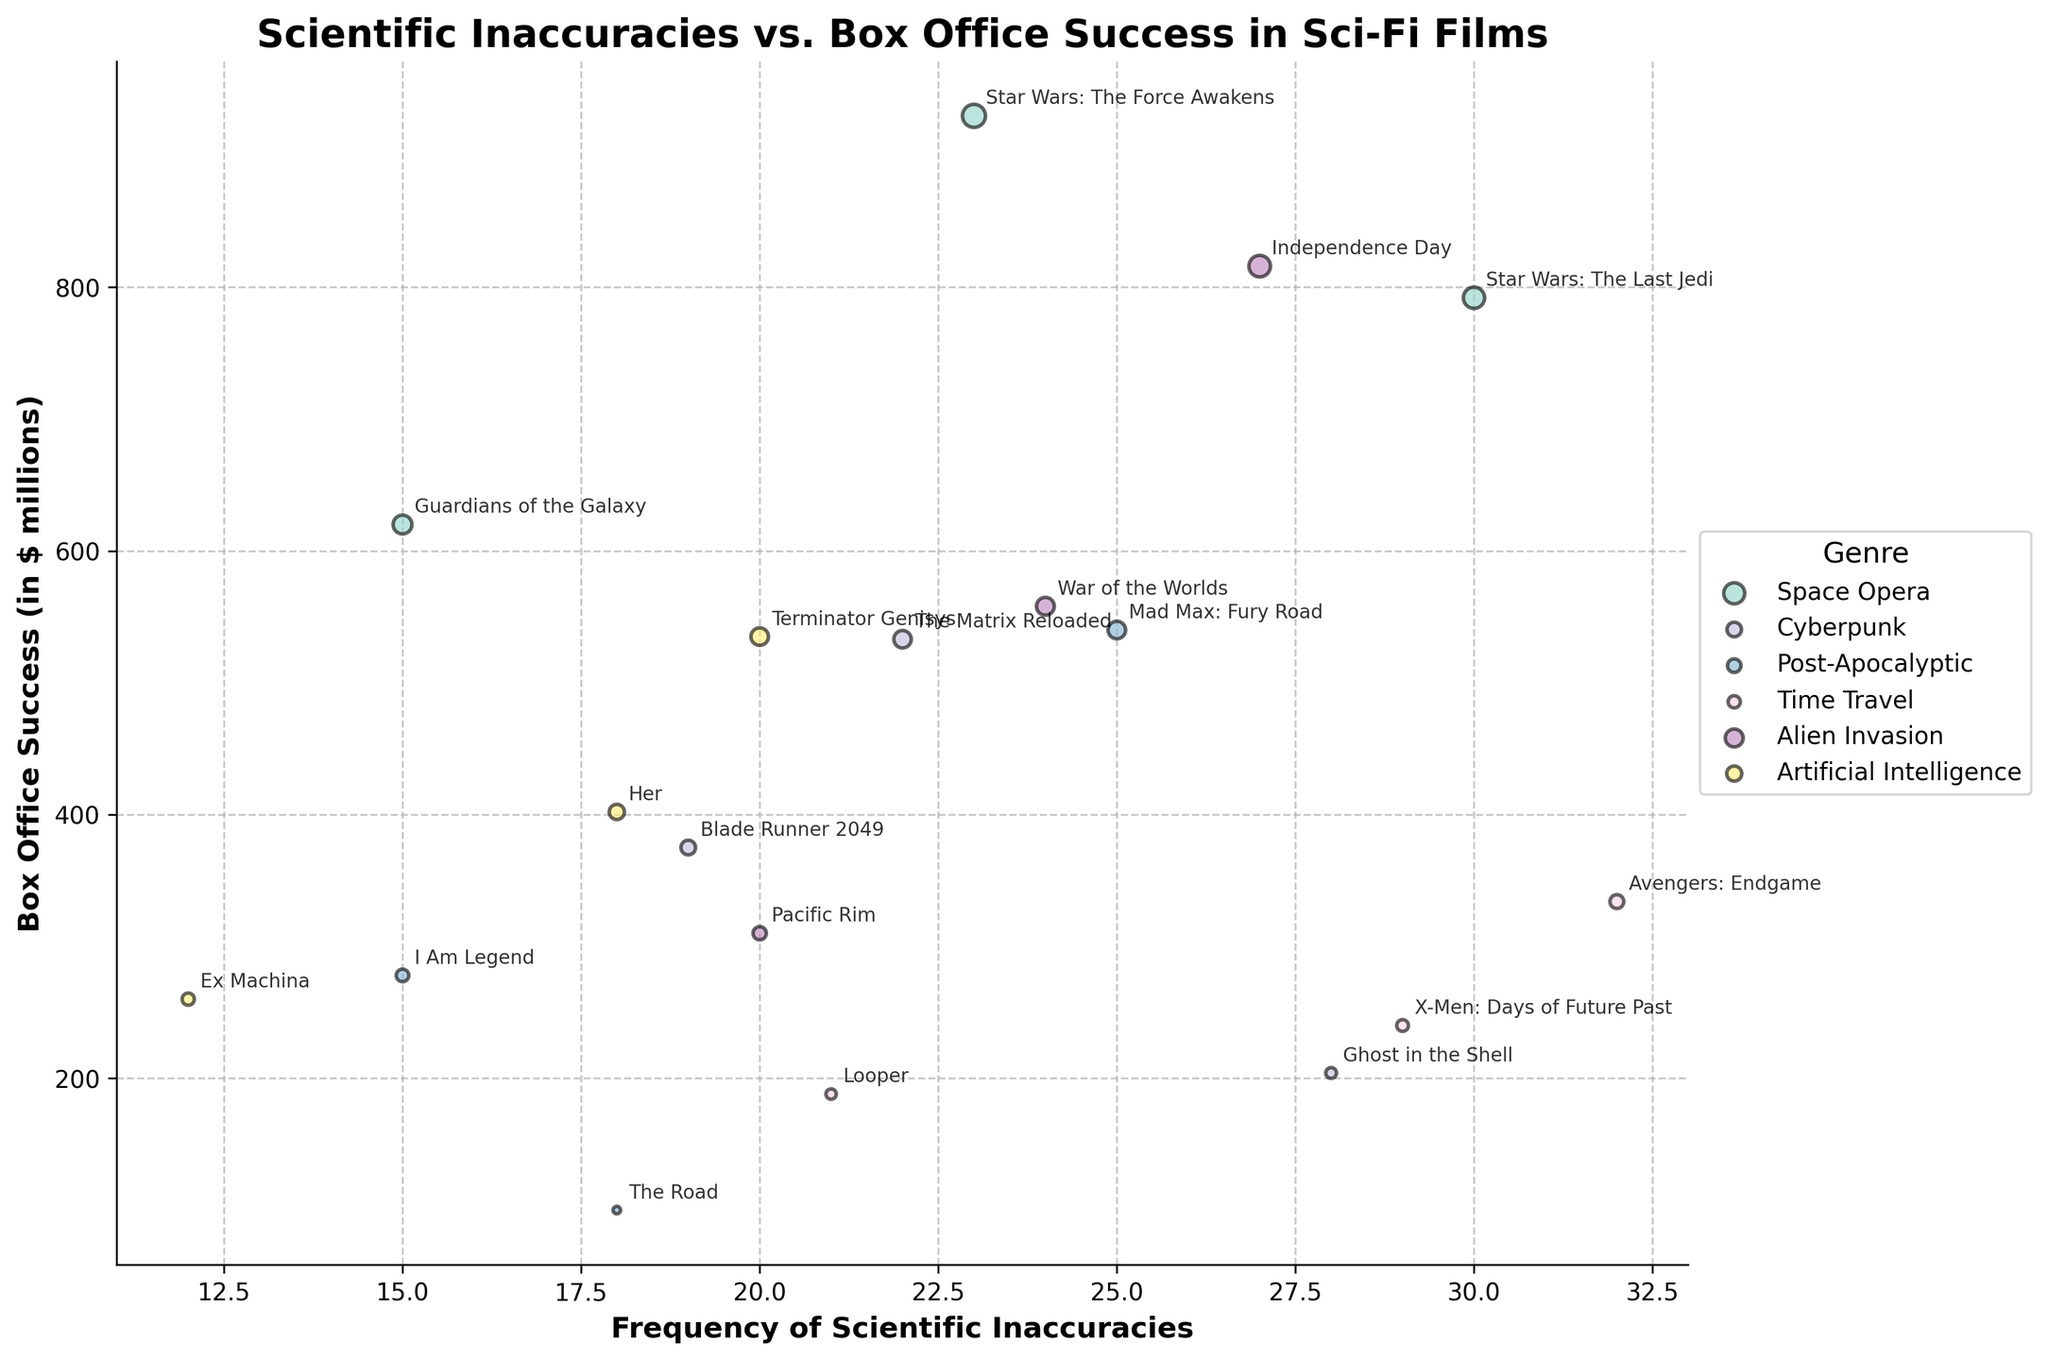How many genres are represented in the figure? The figure uses different colors to represent various genres. Based on the color legend, we can count the number of distinct genres.
Answer: 5 Which film has the highest frequency of scientific inaccuracies, and what genre does it belong to? The film with the highest frequency of scientific inaccuracies has the furthest right bubble. This film is "Avengers: Endgame," and belongs to the "Time Travel" genre.
Answer: Avengers: Endgame, Time Travel What is the average box office success of the "Cyberpunk" genre films? Sum the box office success of all "Cyberpunk" films and divide by the number of films in this genre. The films are "Blade Runner 2049" ($375M), "Ghost in the Shell" ($204M), and "The Matrix Reloaded" ($533M). The total is $375 + $204 + $533 = $1112M, divided by 3 films, so the average is $1112/3 ≈ $370.67M.
Answer: $370.67M Which genre has the most consistent frequency of scientific inaccuracies? Consistency can be inferred from how close the bubbles are horizontally (same frequency). Observing the genres, "Artificial Intelligence" exhibits clusters of bubbles close in frequency (12, 18, 20), indicating consistency.
Answer: Artificial Intelligence What is the overall range of box office success observed in the figure? The range is determined by the difference between the highest and lowest box office success values. The highest is "Star Wars: The Force Awakens" with $930M and the lowest is "The Road" with $100M. The range is $930M - $100M = $830M.
Answer: $830M Are there any outliers in the frequency of scientific inaccuracies? If so, which film(s) are they? Outliers can be identified as bubbles far from the general cluster of points. "Avengers: Endgame" with a frequency of 32 stands out as it is the highest, far from the general cluster between 12 and 30 inaccuracies.
Answer: Avengers: Endgame Which films have a box office success greater than $750M and what are their inaccuracies frequencies? Look for bubbles above the $750M mark and check their labels for inaccuracies frequencies. "Star Wars: The Force Awakens" has $930M and 23 inaccuracies, "Star Wars: The Last Jedi" has $792M and 30 inaccuracies.
Answer: Star Wars: The Force Awakens (23), Star Wars: The Last Jedi (30) Compare the film with the highest box office success to the one with the lowest. How do their scientific inaccuracies frequencies differ? Identify the film with the highest box office success ("Star Wars: The Force Awakens" with $930M, 23 inaccuracies) and the one with the lowest ("The Road" with $100M, 18 inaccuracies). The difference in inaccuracies is 23 - 18 = 5.
Answer: 5 How does the box office success of "Post-Apocalyptic" films compare to "Space Opera" films? Average the box office success for each genre and compare. "Post-Apocalyptic" films: ($540M + $100M + $278M) / 3 ≈ $306M. "Space Opera" films: ($930M + $620M + $792M) / 3 ≈ $780.67M. "Space Opera" films have a higher average.
Answer: Higher What pattern, if any, do you observe between the frequency of scientific inaccuracies and box office success by genre? Observe overall trends in the distribution of bubbles by genre. Some genres like "Space Opera" show high box office success with varying inaccuracies, while "Cyperpunk" shows lower box office success with moderate inaccuracies.
Answer: No clear pattern הערה 